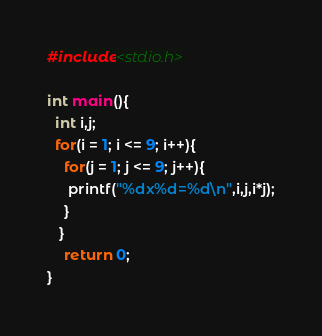<code> <loc_0><loc_0><loc_500><loc_500><_C_>#include<stdio.h>

int main(){
  int i,j;
  for(i = 1; i <= 9; i++){
    for(j = 1; j <= 9; j++){
     printf("%dx%d=%d\n",i,j,i*j);
    }
   }
    return 0;
}</code> 